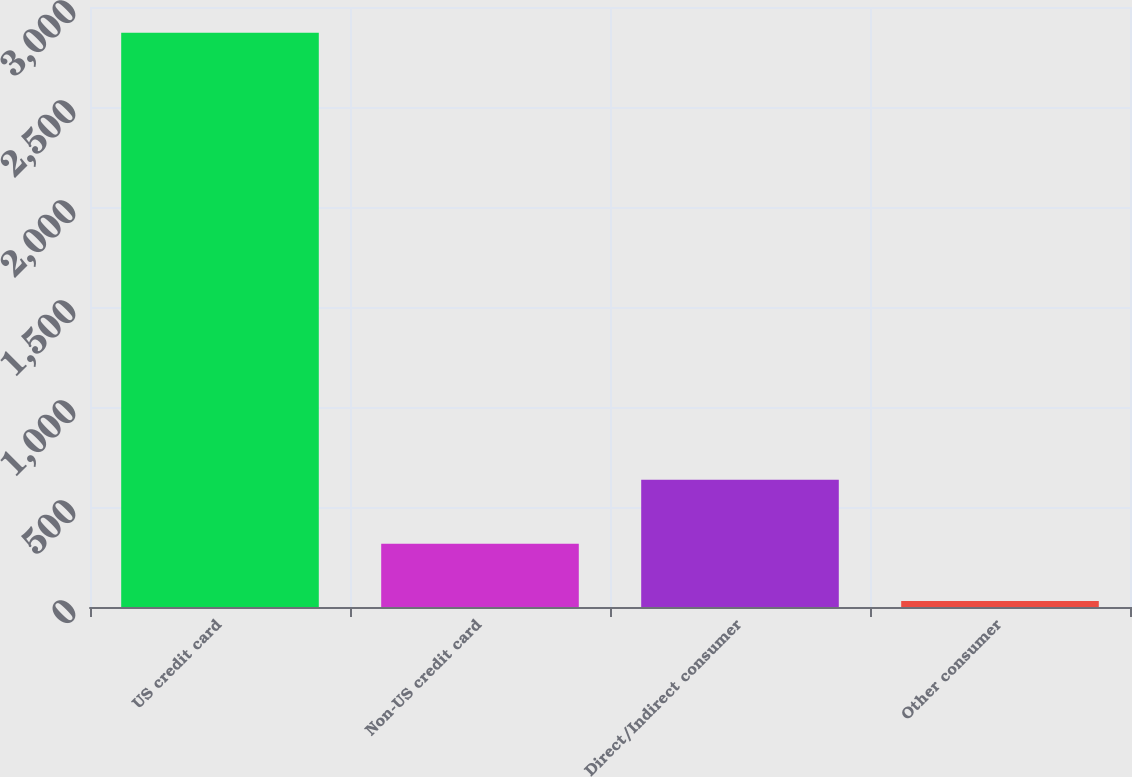<chart> <loc_0><loc_0><loc_500><loc_500><bar_chart><fcel>US credit card<fcel>Non-US credit card<fcel>Direct/Indirect consumer<fcel>Other consumer<nl><fcel>2871<fcel>316<fcel>636<fcel>30<nl></chart> 